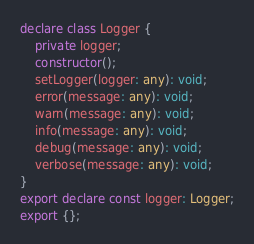<code> <loc_0><loc_0><loc_500><loc_500><_TypeScript_>declare class Logger {
    private logger;
    constructor();
    setLogger(logger: any): void;
    error(message: any): void;
    warn(message: any): void;
    info(message: any): void;
    debug(message: any): void;
    verbose(message: any): void;
}
export declare const logger: Logger;
export {};
</code> 